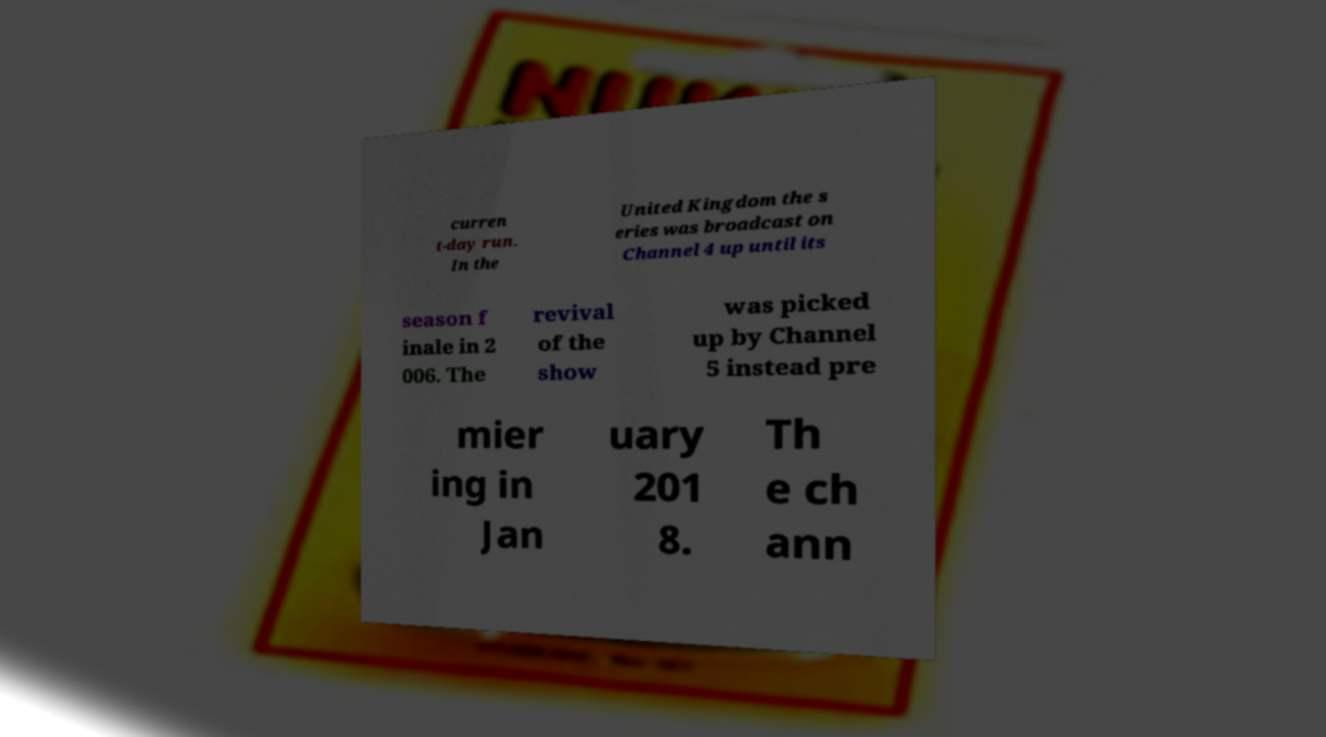Can you read and provide the text displayed in the image?This photo seems to have some interesting text. Can you extract and type it out for me? curren t-day run. In the United Kingdom the s eries was broadcast on Channel 4 up until its season f inale in 2 006. The revival of the show was picked up by Channel 5 instead pre mier ing in Jan uary 201 8. Th e ch ann 